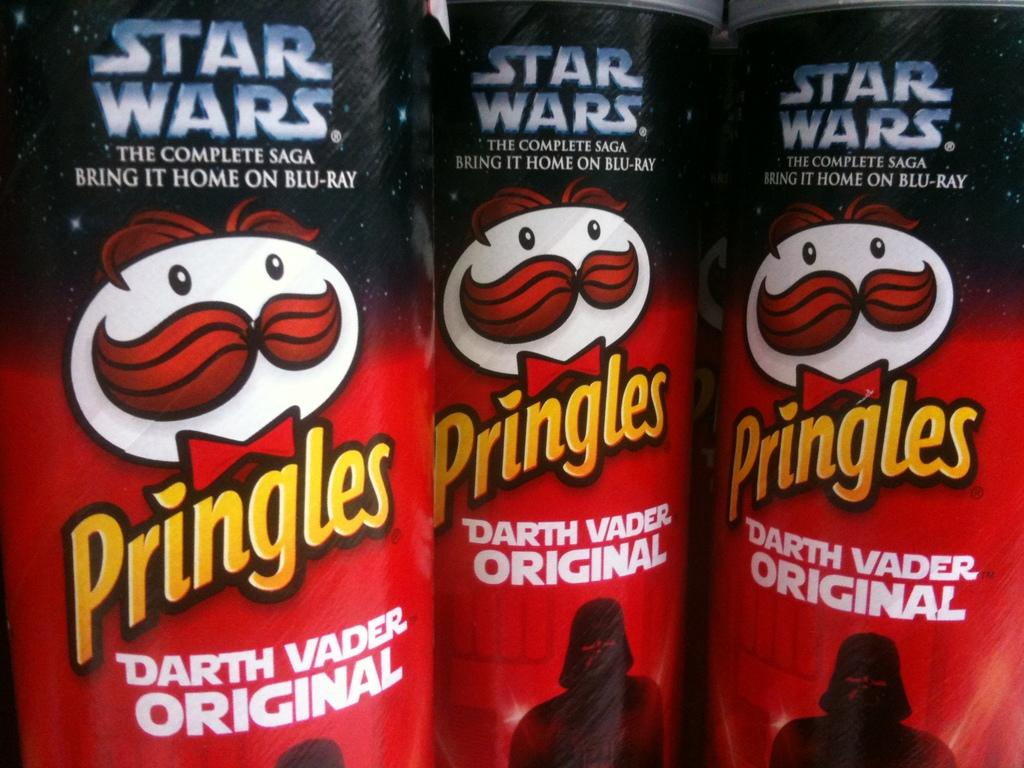<image>
Describe the image concisely. three cans of pringles darth vader original next to each other 